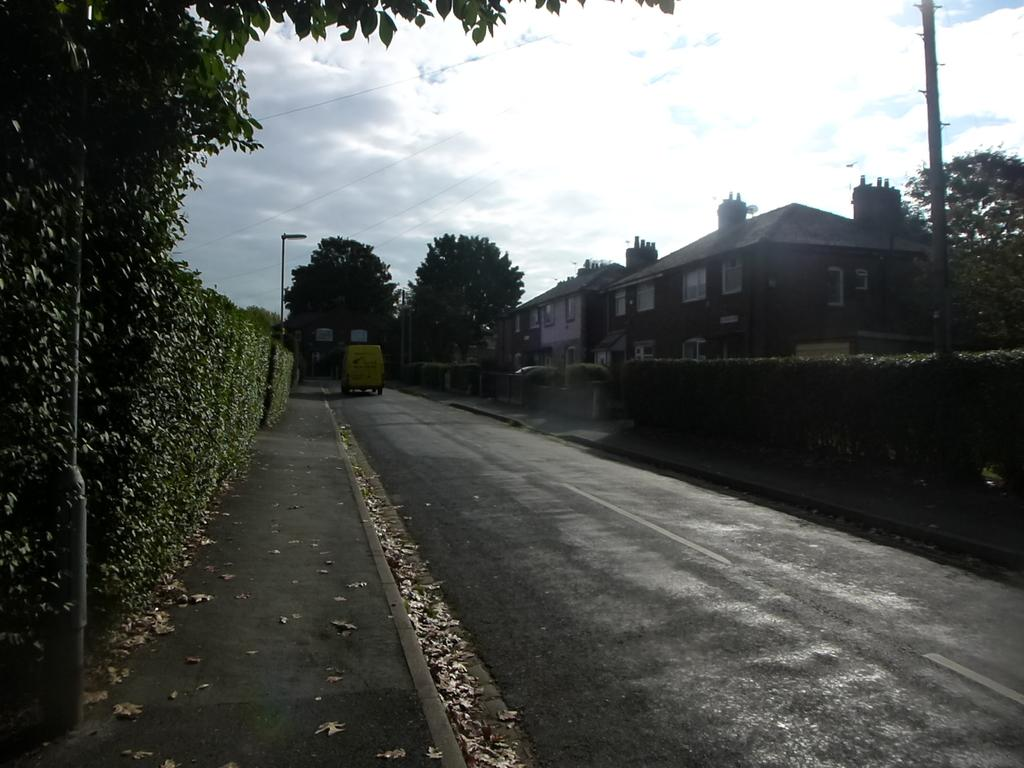What is on the road in the image? There is a vehicle on the road in the image. What type of structures can be seen in the image? There are houses visible in the image. What natural elements are present in the image? There are trees in the image. What type of barrier is present in the image? There is fencing in the image. What is on the ground in the image? Dry leaves are present on the ground in the image. What holiday is being celebrated in the image? There is no indication of a holiday being celebrated in the image. What happens to the tires when the vehicle bursts in the image? There is no indication of a vehicle bursting in the image. 